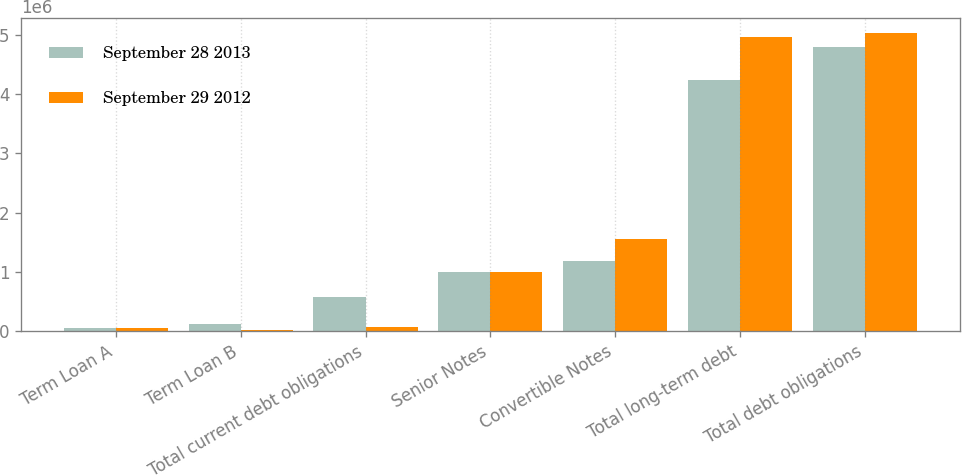Convert chart to OTSL. <chart><loc_0><loc_0><loc_500><loc_500><stacked_bar_chart><ecel><fcel>Term Loan A<fcel>Term Loan B<fcel>Total current debt obligations<fcel>Senior Notes<fcel>Convertible Notes<fcel>Total long-term debt<fcel>Total debt obligations<nl><fcel>September 28 2013<fcel>49713<fcel>113966<fcel>563812<fcel>1e+06<fcel>1.18799e+06<fcel>4.2421e+06<fcel>4.80591e+06<nl><fcel>September 29 2012<fcel>49582<fcel>14853<fcel>64435<fcel>1e+06<fcel>1.55866e+06<fcel>4.97118e+06<fcel>5.03561e+06<nl></chart> 